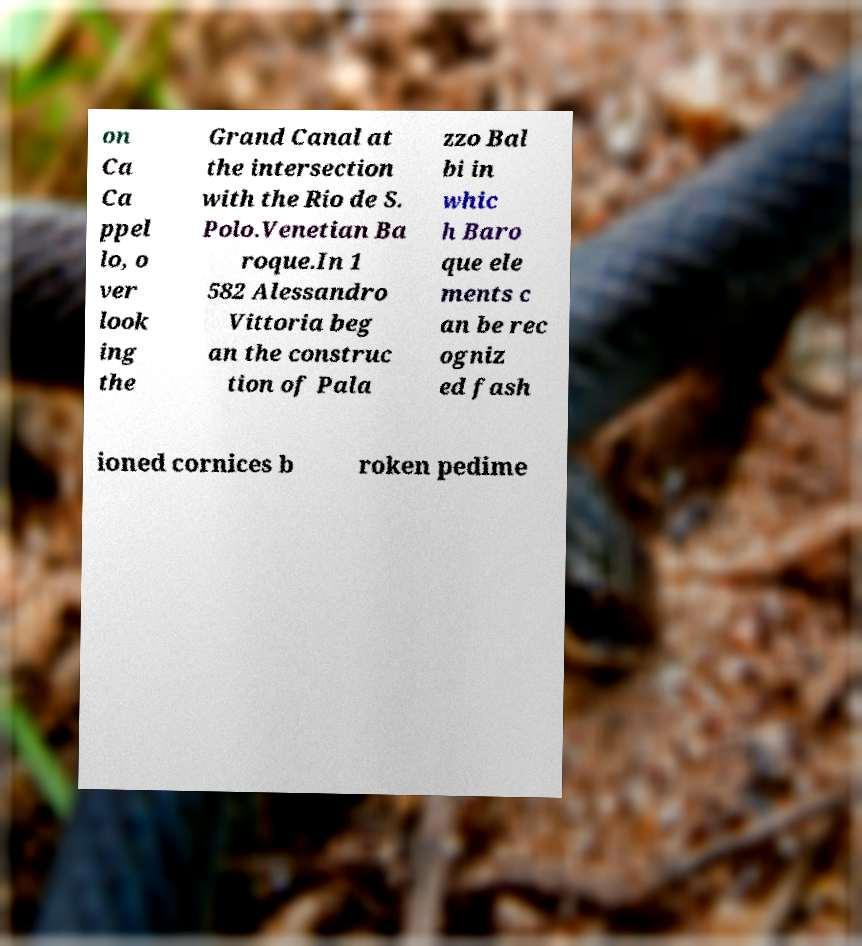Please identify and transcribe the text found in this image. on Ca Ca ppel lo, o ver look ing the Grand Canal at the intersection with the Rio de S. Polo.Venetian Ba roque.In 1 582 Alessandro Vittoria beg an the construc tion of Pala zzo Bal bi in whic h Baro que ele ments c an be rec ogniz ed fash ioned cornices b roken pedime 